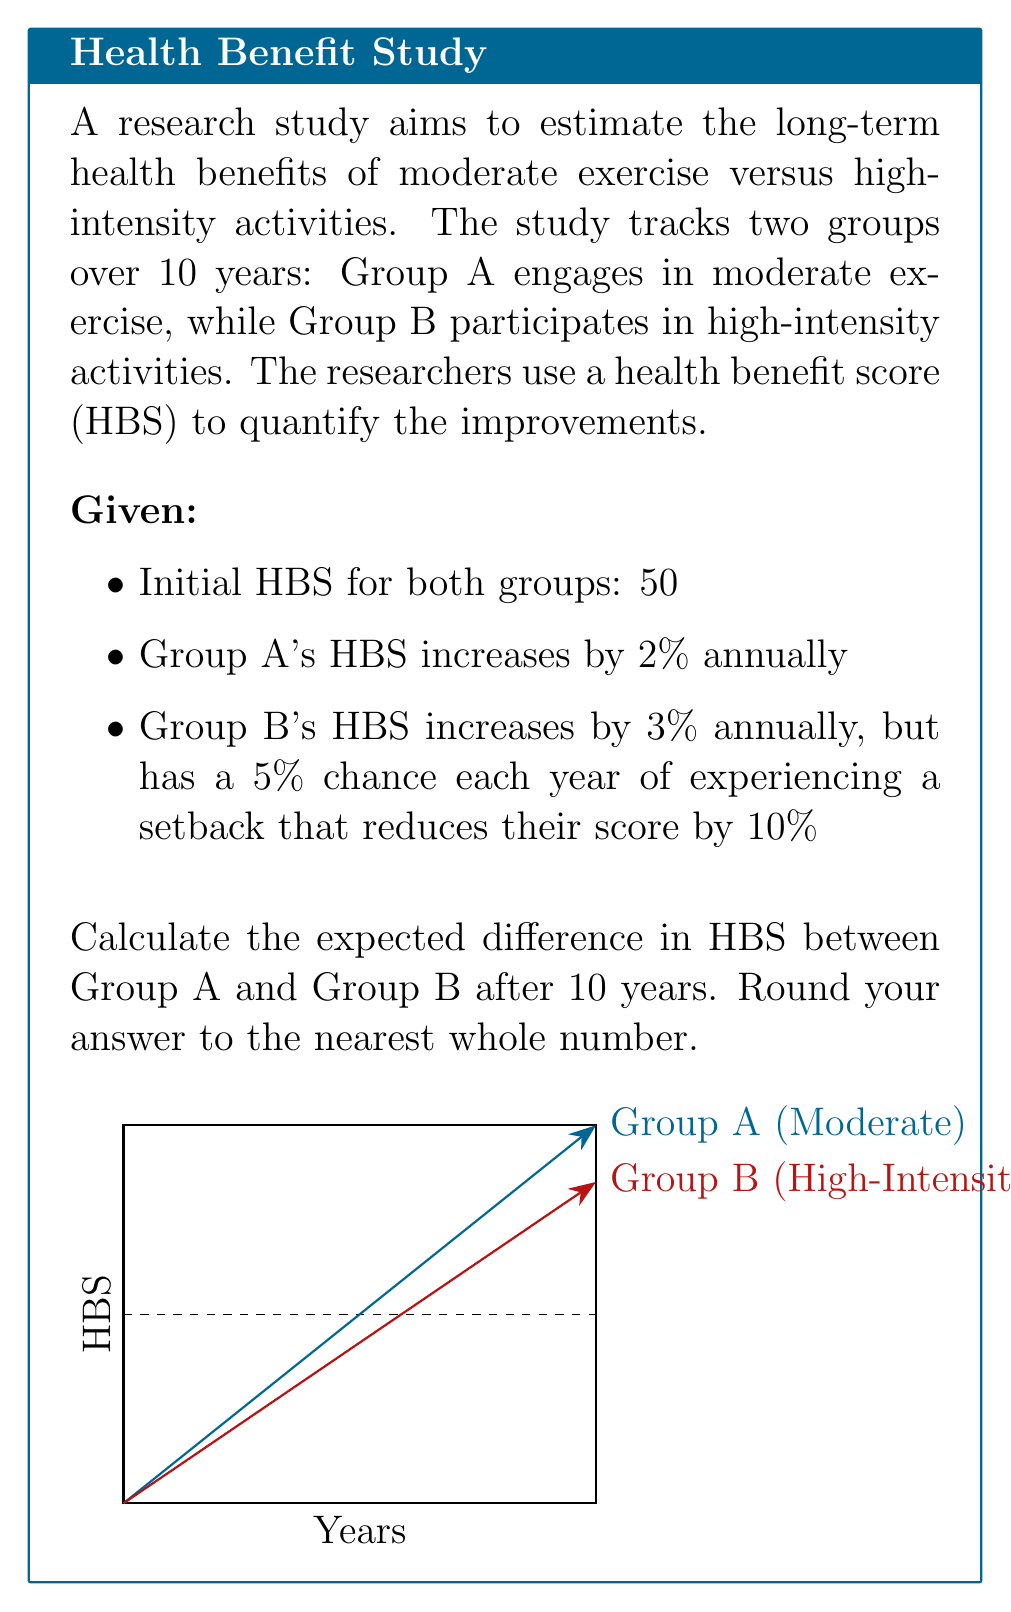Can you solve this math problem? Let's approach this step-by-step:

1) For Group A (moderate exercise):
   The HBS after 10 years can be calculated using the compound interest formula:
   $$HBS_A = 50 \times (1.02)^{10} = 60.95$$

2) For Group B (high-intensity), we need to consider the potential setbacks:
   - Probability of no setback in a year: 0.95
   - Probability of a setback: 0.05

   Let's calculate the expected HBS for each year:

   Year 1: $50 \times (1.03 \times 0.95 + 0.90 \times 0.05) = 51.175$
   Year 2: $51.175 \times (1.03 \times 0.95 + 0.90 \times 0.05) = 52.37$
   ...

   We can generalize this as:
   $$HBS_B = 50 \times (1.03 \times 0.95 + 0.90 \times 0.05)^{10}$$

3) Calculate $HBS_B$:
   $$HBS_B = 50 \times (0.9785)^{10} = 59.87$$

4) Calculate the difference:
   $$Difference = HBS_A - HBS_B = 60.95 - 59.87 = 1.08$$

5) Rounding to the nearest whole number:
   $$Rounded\ Difference = 1$$
Answer: 1 